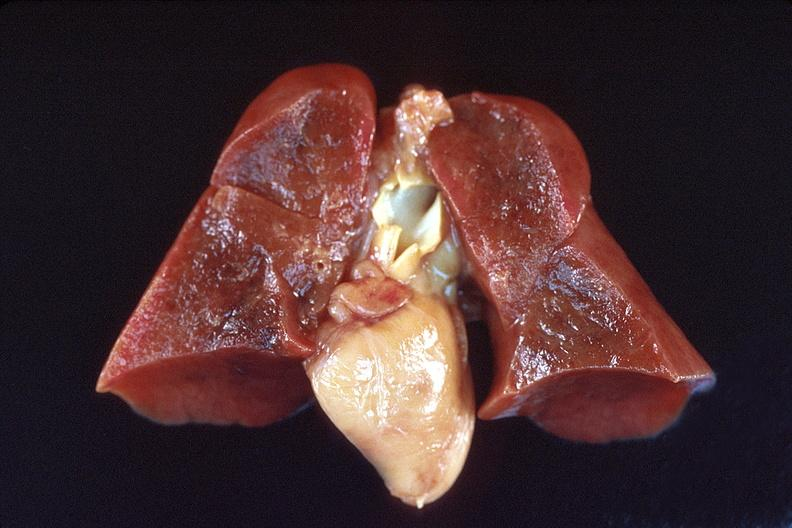what is present?
Answer the question using a single word or phrase. Respiratory 